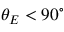<formula> <loc_0><loc_0><loc_500><loc_500>\theta _ { E } < 9 0 ^ { \circ }</formula> 